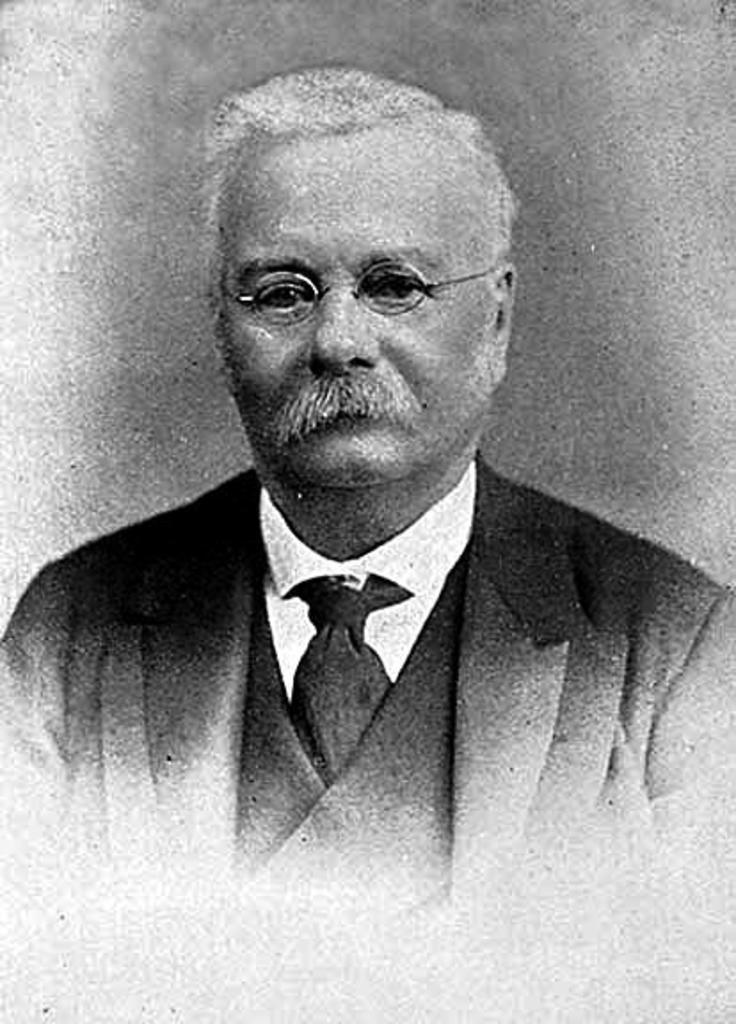Please provide a concise description of this image. It is a black and white image. In this image there is a person wearing a spectacle. 